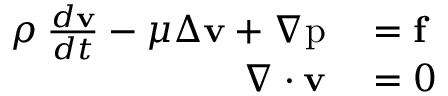Convert formula to latex. <formula><loc_0><loc_0><loc_500><loc_500>\begin{array} { r l } { \rho \, \frac { d v } { d t } - \mu \Delta v + \nabla p } & = f } \\ { \nabla \cdot v } & = 0 } \end{array}</formula> 